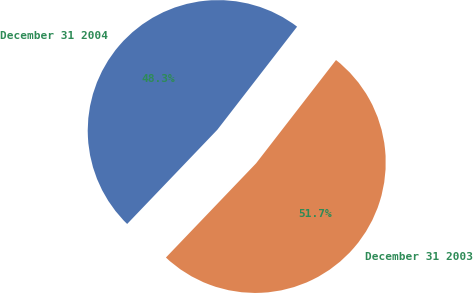<chart> <loc_0><loc_0><loc_500><loc_500><pie_chart><fcel>December 31 2004<fcel>December 31 2003<nl><fcel>48.33%<fcel>51.67%<nl></chart> 